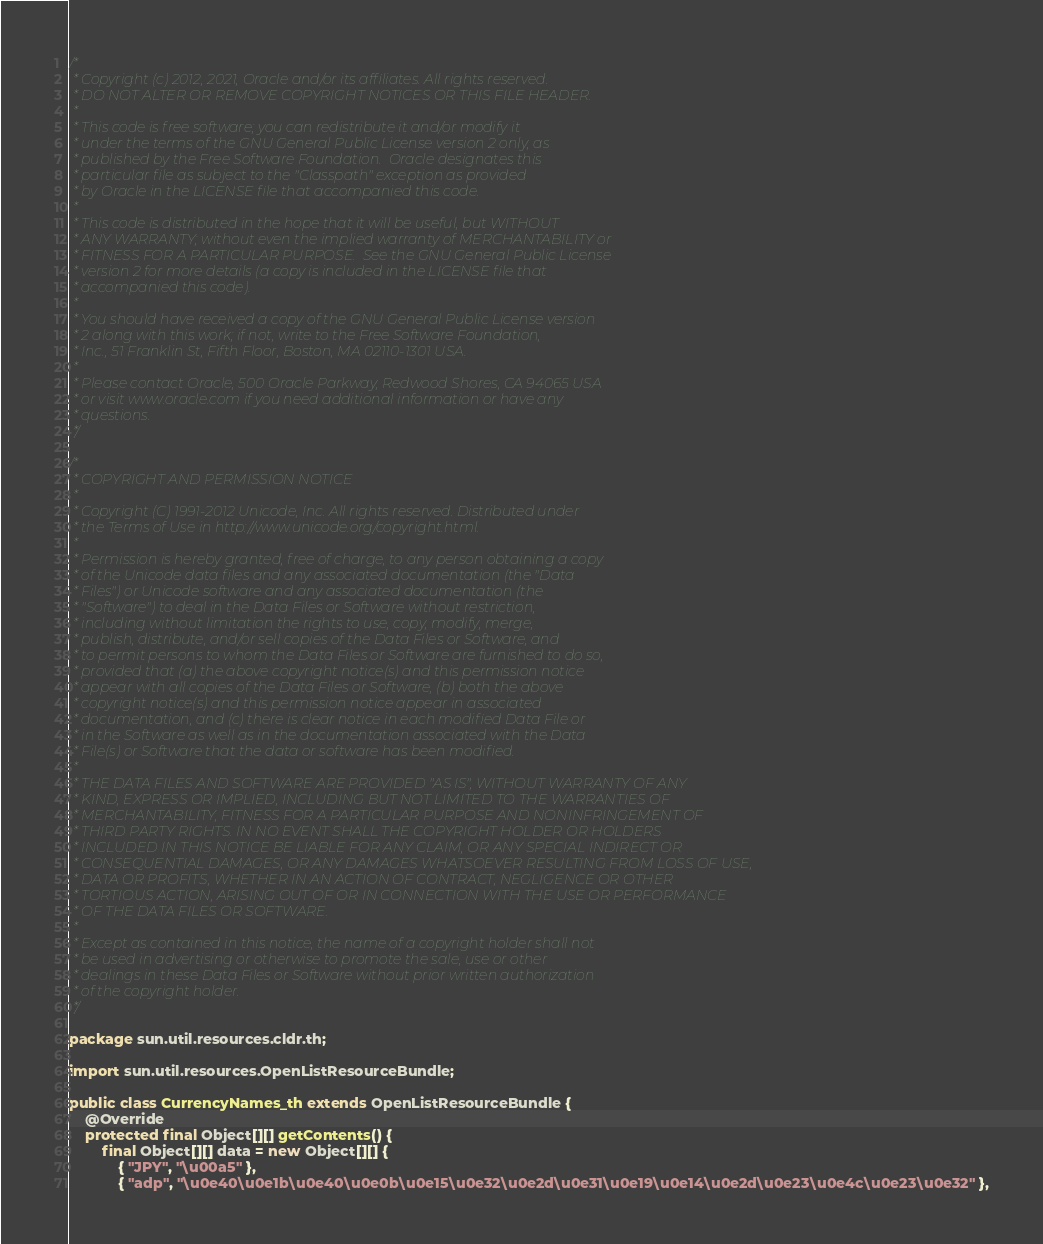<code> <loc_0><loc_0><loc_500><loc_500><_Java_>/*
 * Copyright (c) 2012, 2021, Oracle and/or its affiliates. All rights reserved.
 * DO NOT ALTER OR REMOVE COPYRIGHT NOTICES OR THIS FILE HEADER.
 *
 * This code is free software; you can redistribute it and/or modify it
 * under the terms of the GNU General Public License version 2 only, as
 * published by the Free Software Foundation.  Oracle designates this
 * particular file as subject to the "Classpath" exception as provided
 * by Oracle in the LICENSE file that accompanied this code.
 *
 * This code is distributed in the hope that it will be useful, but WITHOUT
 * ANY WARRANTY; without even the implied warranty of MERCHANTABILITY or
 * FITNESS FOR A PARTICULAR PURPOSE.  See the GNU General Public License
 * version 2 for more details (a copy is included in the LICENSE file that
 * accompanied this code).
 *
 * You should have received a copy of the GNU General Public License version
 * 2 along with this work; if not, write to the Free Software Foundation,
 * Inc., 51 Franklin St, Fifth Floor, Boston, MA 02110-1301 USA.
 *
 * Please contact Oracle, 500 Oracle Parkway, Redwood Shores, CA 94065 USA
 * or visit www.oracle.com if you need additional information or have any
 * questions.
 */

/*
 * COPYRIGHT AND PERMISSION NOTICE
 *
 * Copyright (C) 1991-2012 Unicode, Inc. All rights reserved. Distributed under
 * the Terms of Use in http://www.unicode.org/copyright.html.
 *
 * Permission is hereby granted, free of charge, to any person obtaining a copy
 * of the Unicode data files and any associated documentation (the "Data
 * Files") or Unicode software and any associated documentation (the
 * "Software") to deal in the Data Files or Software without restriction,
 * including without limitation the rights to use, copy, modify, merge,
 * publish, distribute, and/or sell copies of the Data Files or Software, and
 * to permit persons to whom the Data Files or Software are furnished to do so,
 * provided that (a) the above copyright notice(s) and this permission notice
 * appear with all copies of the Data Files or Software, (b) both the above
 * copyright notice(s) and this permission notice appear in associated
 * documentation, and (c) there is clear notice in each modified Data File or
 * in the Software as well as in the documentation associated with the Data
 * File(s) or Software that the data or software has been modified.
 *
 * THE DATA FILES AND SOFTWARE ARE PROVIDED "AS IS", WITHOUT WARRANTY OF ANY
 * KIND, EXPRESS OR IMPLIED, INCLUDING BUT NOT LIMITED TO THE WARRANTIES OF
 * MERCHANTABILITY, FITNESS FOR A PARTICULAR PURPOSE AND NONINFRINGEMENT OF
 * THIRD PARTY RIGHTS. IN NO EVENT SHALL THE COPYRIGHT HOLDER OR HOLDERS
 * INCLUDED IN THIS NOTICE BE LIABLE FOR ANY CLAIM, OR ANY SPECIAL INDIRECT OR
 * CONSEQUENTIAL DAMAGES, OR ANY DAMAGES WHATSOEVER RESULTING FROM LOSS OF USE,
 * DATA OR PROFITS, WHETHER IN AN ACTION OF CONTRACT, NEGLIGENCE OR OTHER
 * TORTIOUS ACTION, ARISING OUT OF OR IN CONNECTION WITH THE USE OR PERFORMANCE
 * OF THE DATA FILES OR SOFTWARE.
 *
 * Except as contained in this notice, the name of a copyright holder shall not
 * be used in advertising or otherwise to promote the sale, use or other
 * dealings in these Data Files or Software without prior written authorization
 * of the copyright holder.
 */

package sun.util.resources.cldr.th;

import sun.util.resources.OpenListResourceBundle;

public class CurrencyNames_th extends OpenListResourceBundle {
    @Override
    protected final Object[][] getContents() {
        final Object[][] data = new Object[][] {
            { "JPY", "\u00a5" },
            { "adp", "\u0e40\u0e1b\u0e40\u0e0b\u0e15\u0e32\u0e2d\u0e31\u0e19\u0e14\u0e2d\u0e23\u0e4c\u0e23\u0e32" },</code> 